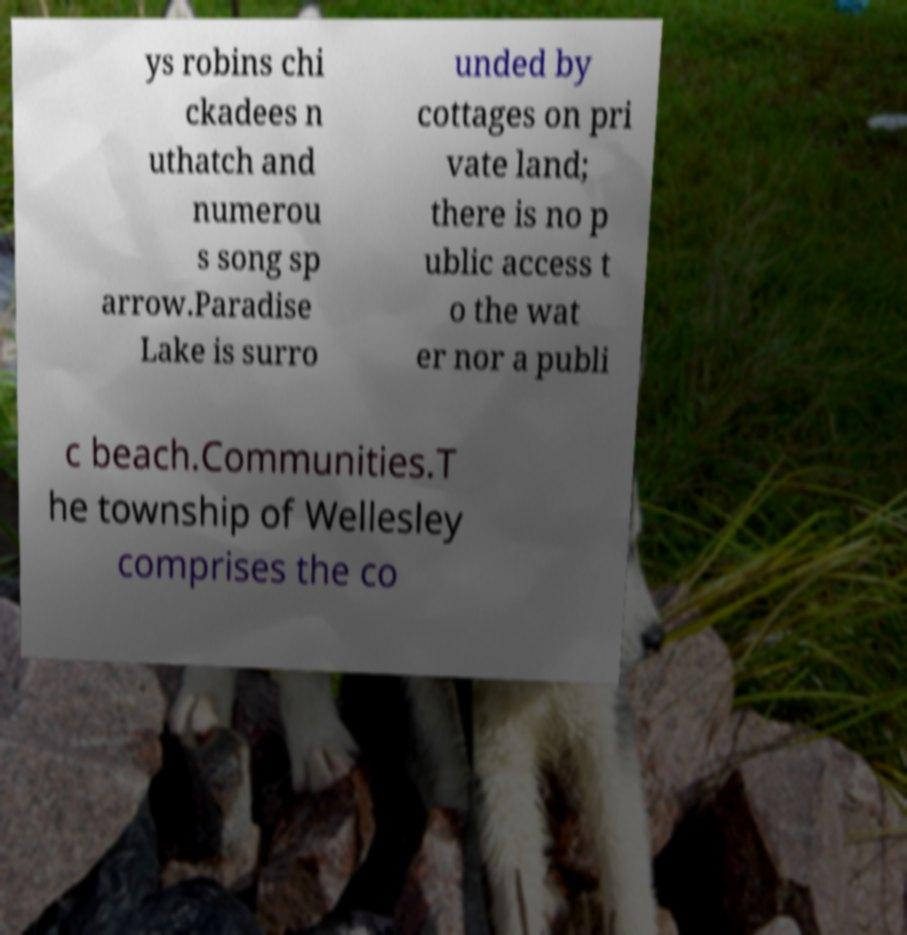Please identify and transcribe the text found in this image. ys robins chi ckadees n uthatch and numerou s song sp arrow.Paradise Lake is surro unded by cottages on pri vate land; there is no p ublic access t o the wat er nor a publi c beach.Communities.T he township of Wellesley comprises the co 